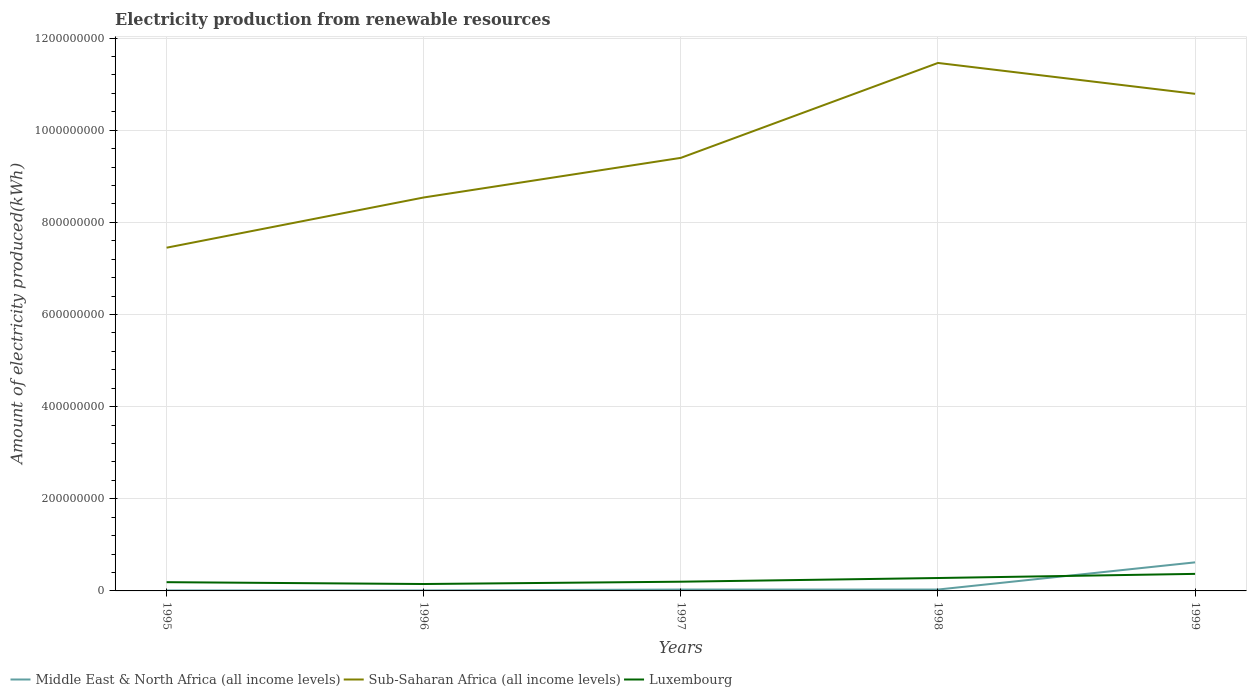Across all years, what is the maximum amount of electricity produced in Luxembourg?
Provide a succinct answer. 1.50e+07. What is the total amount of electricity produced in Sub-Saharan Africa (all income levels) in the graph?
Ensure brevity in your answer.  -1.39e+08. What is the difference between the highest and the second highest amount of electricity produced in Sub-Saharan Africa (all income levels)?
Your answer should be compact. 4.01e+08. What is the difference between the highest and the lowest amount of electricity produced in Sub-Saharan Africa (all income levels)?
Give a very brief answer. 2. Is the amount of electricity produced in Middle East & North Africa (all income levels) strictly greater than the amount of electricity produced in Sub-Saharan Africa (all income levels) over the years?
Offer a very short reply. Yes. How many years are there in the graph?
Your answer should be very brief. 5. What is the difference between two consecutive major ticks on the Y-axis?
Provide a succinct answer. 2.00e+08. Are the values on the major ticks of Y-axis written in scientific E-notation?
Provide a succinct answer. No. Where does the legend appear in the graph?
Offer a terse response. Bottom left. How many legend labels are there?
Your answer should be compact. 3. How are the legend labels stacked?
Provide a succinct answer. Horizontal. What is the title of the graph?
Make the answer very short. Electricity production from renewable resources. Does "Haiti" appear as one of the legend labels in the graph?
Your response must be concise. No. What is the label or title of the Y-axis?
Your answer should be compact. Amount of electricity produced(kWh). What is the Amount of electricity produced(kWh) in Middle East & North Africa (all income levels) in 1995?
Give a very brief answer. 1.00e+06. What is the Amount of electricity produced(kWh) of Sub-Saharan Africa (all income levels) in 1995?
Provide a short and direct response. 7.45e+08. What is the Amount of electricity produced(kWh) of Luxembourg in 1995?
Offer a terse response. 1.90e+07. What is the Amount of electricity produced(kWh) of Sub-Saharan Africa (all income levels) in 1996?
Keep it short and to the point. 8.54e+08. What is the Amount of electricity produced(kWh) of Luxembourg in 1996?
Your response must be concise. 1.50e+07. What is the Amount of electricity produced(kWh) in Sub-Saharan Africa (all income levels) in 1997?
Your answer should be compact. 9.40e+08. What is the Amount of electricity produced(kWh) in Luxembourg in 1997?
Provide a succinct answer. 2.00e+07. What is the Amount of electricity produced(kWh) in Middle East & North Africa (all income levels) in 1998?
Offer a terse response. 3.00e+06. What is the Amount of electricity produced(kWh) in Sub-Saharan Africa (all income levels) in 1998?
Provide a short and direct response. 1.15e+09. What is the Amount of electricity produced(kWh) in Luxembourg in 1998?
Provide a succinct answer. 2.80e+07. What is the Amount of electricity produced(kWh) of Middle East & North Africa (all income levels) in 1999?
Your answer should be very brief. 6.20e+07. What is the Amount of electricity produced(kWh) in Sub-Saharan Africa (all income levels) in 1999?
Offer a very short reply. 1.08e+09. What is the Amount of electricity produced(kWh) in Luxembourg in 1999?
Provide a short and direct response. 3.70e+07. Across all years, what is the maximum Amount of electricity produced(kWh) in Middle East & North Africa (all income levels)?
Keep it short and to the point. 6.20e+07. Across all years, what is the maximum Amount of electricity produced(kWh) in Sub-Saharan Africa (all income levels)?
Your answer should be very brief. 1.15e+09. Across all years, what is the maximum Amount of electricity produced(kWh) in Luxembourg?
Provide a short and direct response. 3.70e+07. Across all years, what is the minimum Amount of electricity produced(kWh) in Middle East & North Africa (all income levels)?
Your answer should be very brief. 1.00e+06. Across all years, what is the minimum Amount of electricity produced(kWh) of Sub-Saharan Africa (all income levels)?
Make the answer very short. 7.45e+08. Across all years, what is the minimum Amount of electricity produced(kWh) in Luxembourg?
Ensure brevity in your answer.  1.50e+07. What is the total Amount of electricity produced(kWh) in Middle East & North Africa (all income levels) in the graph?
Ensure brevity in your answer.  7.00e+07. What is the total Amount of electricity produced(kWh) in Sub-Saharan Africa (all income levels) in the graph?
Give a very brief answer. 4.76e+09. What is the total Amount of electricity produced(kWh) of Luxembourg in the graph?
Provide a succinct answer. 1.19e+08. What is the difference between the Amount of electricity produced(kWh) of Middle East & North Africa (all income levels) in 1995 and that in 1996?
Give a very brief answer. 0. What is the difference between the Amount of electricity produced(kWh) of Sub-Saharan Africa (all income levels) in 1995 and that in 1996?
Offer a terse response. -1.09e+08. What is the difference between the Amount of electricity produced(kWh) of Luxembourg in 1995 and that in 1996?
Offer a terse response. 4.00e+06. What is the difference between the Amount of electricity produced(kWh) of Sub-Saharan Africa (all income levels) in 1995 and that in 1997?
Keep it short and to the point. -1.95e+08. What is the difference between the Amount of electricity produced(kWh) in Sub-Saharan Africa (all income levels) in 1995 and that in 1998?
Make the answer very short. -4.01e+08. What is the difference between the Amount of electricity produced(kWh) in Luxembourg in 1995 and that in 1998?
Offer a very short reply. -9.00e+06. What is the difference between the Amount of electricity produced(kWh) in Middle East & North Africa (all income levels) in 1995 and that in 1999?
Provide a succinct answer. -6.10e+07. What is the difference between the Amount of electricity produced(kWh) in Sub-Saharan Africa (all income levels) in 1995 and that in 1999?
Offer a very short reply. -3.34e+08. What is the difference between the Amount of electricity produced(kWh) of Luxembourg in 1995 and that in 1999?
Ensure brevity in your answer.  -1.80e+07. What is the difference between the Amount of electricity produced(kWh) in Middle East & North Africa (all income levels) in 1996 and that in 1997?
Your response must be concise. -2.00e+06. What is the difference between the Amount of electricity produced(kWh) in Sub-Saharan Africa (all income levels) in 1996 and that in 1997?
Offer a terse response. -8.60e+07. What is the difference between the Amount of electricity produced(kWh) in Luxembourg in 1996 and that in 1997?
Offer a terse response. -5.00e+06. What is the difference between the Amount of electricity produced(kWh) in Middle East & North Africa (all income levels) in 1996 and that in 1998?
Your answer should be compact. -2.00e+06. What is the difference between the Amount of electricity produced(kWh) in Sub-Saharan Africa (all income levels) in 1996 and that in 1998?
Provide a short and direct response. -2.92e+08. What is the difference between the Amount of electricity produced(kWh) in Luxembourg in 1996 and that in 1998?
Your answer should be very brief. -1.30e+07. What is the difference between the Amount of electricity produced(kWh) of Middle East & North Africa (all income levels) in 1996 and that in 1999?
Offer a very short reply. -6.10e+07. What is the difference between the Amount of electricity produced(kWh) in Sub-Saharan Africa (all income levels) in 1996 and that in 1999?
Your answer should be very brief. -2.25e+08. What is the difference between the Amount of electricity produced(kWh) in Luxembourg in 1996 and that in 1999?
Ensure brevity in your answer.  -2.20e+07. What is the difference between the Amount of electricity produced(kWh) in Middle East & North Africa (all income levels) in 1997 and that in 1998?
Offer a very short reply. 0. What is the difference between the Amount of electricity produced(kWh) of Sub-Saharan Africa (all income levels) in 1997 and that in 1998?
Your response must be concise. -2.06e+08. What is the difference between the Amount of electricity produced(kWh) of Luxembourg in 1997 and that in 1998?
Keep it short and to the point. -8.00e+06. What is the difference between the Amount of electricity produced(kWh) of Middle East & North Africa (all income levels) in 1997 and that in 1999?
Your response must be concise. -5.90e+07. What is the difference between the Amount of electricity produced(kWh) of Sub-Saharan Africa (all income levels) in 1997 and that in 1999?
Make the answer very short. -1.39e+08. What is the difference between the Amount of electricity produced(kWh) of Luxembourg in 1997 and that in 1999?
Offer a very short reply. -1.70e+07. What is the difference between the Amount of electricity produced(kWh) of Middle East & North Africa (all income levels) in 1998 and that in 1999?
Your answer should be very brief. -5.90e+07. What is the difference between the Amount of electricity produced(kWh) of Sub-Saharan Africa (all income levels) in 1998 and that in 1999?
Your answer should be very brief. 6.70e+07. What is the difference between the Amount of electricity produced(kWh) of Luxembourg in 1998 and that in 1999?
Provide a succinct answer. -9.00e+06. What is the difference between the Amount of electricity produced(kWh) of Middle East & North Africa (all income levels) in 1995 and the Amount of electricity produced(kWh) of Sub-Saharan Africa (all income levels) in 1996?
Your response must be concise. -8.53e+08. What is the difference between the Amount of electricity produced(kWh) in Middle East & North Africa (all income levels) in 1995 and the Amount of electricity produced(kWh) in Luxembourg in 1996?
Provide a short and direct response. -1.40e+07. What is the difference between the Amount of electricity produced(kWh) in Sub-Saharan Africa (all income levels) in 1995 and the Amount of electricity produced(kWh) in Luxembourg in 1996?
Keep it short and to the point. 7.30e+08. What is the difference between the Amount of electricity produced(kWh) in Middle East & North Africa (all income levels) in 1995 and the Amount of electricity produced(kWh) in Sub-Saharan Africa (all income levels) in 1997?
Keep it short and to the point. -9.39e+08. What is the difference between the Amount of electricity produced(kWh) in Middle East & North Africa (all income levels) in 1995 and the Amount of electricity produced(kWh) in Luxembourg in 1997?
Offer a terse response. -1.90e+07. What is the difference between the Amount of electricity produced(kWh) in Sub-Saharan Africa (all income levels) in 1995 and the Amount of electricity produced(kWh) in Luxembourg in 1997?
Provide a short and direct response. 7.25e+08. What is the difference between the Amount of electricity produced(kWh) of Middle East & North Africa (all income levels) in 1995 and the Amount of electricity produced(kWh) of Sub-Saharan Africa (all income levels) in 1998?
Provide a short and direct response. -1.14e+09. What is the difference between the Amount of electricity produced(kWh) of Middle East & North Africa (all income levels) in 1995 and the Amount of electricity produced(kWh) of Luxembourg in 1998?
Your answer should be very brief. -2.70e+07. What is the difference between the Amount of electricity produced(kWh) in Sub-Saharan Africa (all income levels) in 1995 and the Amount of electricity produced(kWh) in Luxembourg in 1998?
Provide a short and direct response. 7.17e+08. What is the difference between the Amount of electricity produced(kWh) of Middle East & North Africa (all income levels) in 1995 and the Amount of electricity produced(kWh) of Sub-Saharan Africa (all income levels) in 1999?
Keep it short and to the point. -1.08e+09. What is the difference between the Amount of electricity produced(kWh) of Middle East & North Africa (all income levels) in 1995 and the Amount of electricity produced(kWh) of Luxembourg in 1999?
Keep it short and to the point. -3.60e+07. What is the difference between the Amount of electricity produced(kWh) in Sub-Saharan Africa (all income levels) in 1995 and the Amount of electricity produced(kWh) in Luxembourg in 1999?
Your answer should be compact. 7.08e+08. What is the difference between the Amount of electricity produced(kWh) of Middle East & North Africa (all income levels) in 1996 and the Amount of electricity produced(kWh) of Sub-Saharan Africa (all income levels) in 1997?
Keep it short and to the point. -9.39e+08. What is the difference between the Amount of electricity produced(kWh) of Middle East & North Africa (all income levels) in 1996 and the Amount of electricity produced(kWh) of Luxembourg in 1997?
Your response must be concise. -1.90e+07. What is the difference between the Amount of electricity produced(kWh) in Sub-Saharan Africa (all income levels) in 1996 and the Amount of electricity produced(kWh) in Luxembourg in 1997?
Offer a very short reply. 8.34e+08. What is the difference between the Amount of electricity produced(kWh) of Middle East & North Africa (all income levels) in 1996 and the Amount of electricity produced(kWh) of Sub-Saharan Africa (all income levels) in 1998?
Give a very brief answer. -1.14e+09. What is the difference between the Amount of electricity produced(kWh) in Middle East & North Africa (all income levels) in 1996 and the Amount of electricity produced(kWh) in Luxembourg in 1998?
Your response must be concise. -2.70e+07. What is the difference between the Amount of electricity produced(kWh) of Sub-Saharan Africa (all income levels) in 1996 and the Amount of electricity produced(kWh) of Luxembourg in 1998?
Your answer should be compact. 8.26e+08. What is the difference between the Amount of electricity produced(kWh) in Middle East & North Africa (all income levels) in 1996 and the Amount of electricity produced(kWh) in Sub-Saharan Africa (all income levels) in 1999?
Ensure brevity in your answer.  -1.08e+09. What is the difference between the Amount of electricity produced(kWh) of Middle East & North Africa (all income levels) in 1996 and the Amount of electricity produced(kWh) of Luxembourg in 1999?
Keep it short and to the point. -3.60e+07. What is the difference between the Amount of electricity produced(kWh) in Sub-Saharan Africa (all income levels) in 1996 and the Amount of electricity produced(kWh) in Luxembourg in 1999?
Give a very brief answer. 8.17e+08. What is the difference between the Amount of electricity produced(kWh) of Middle East & North Africa (all income levels) in 1997 and the Amount of electricity produced(kWh) of Sub-Saharan Africa (all income levels) in 1998?
Give a very brief answer. -1.14e+09. What is the difference between the Amount of electricity produced(kWh) of Middle East & North Africa (all income levels) in 1997 and the Amount of electricity produced(kWh) of Luxembourg in 1998?
Give a very brief answer. -2.50e+07. What is the difference between the Amount of electricity produced(kWh) in Sub-Saharan Africa (all income levels) in 1997 and the Amount of electricity produced(kWh) in Luxembourg in 1998?
Keep it short and to the point. 9.12e+08. What is the difference between the Amount of electricity produced(kWh) of Middle East & North Africa (all income levels) in 1997 and the Amount of electricity produced(kWh) of Sub-Saharan Africa (all income levels) in 1999?
Your answer should be very brief. -1.08e+09. What is the difference between the Amount of electricity produced(kWh) in Middle East & North Africa (all income levels) in 1997 and the Amount of electricity produced(kWh) in Luxembourg in 1999?
Offer a terse response. -3.40e+07. What is the difference between the Amount of electricity produced(kWh) in Sub-Saharan Africa (all income levels) in 1997 and the Amount of electricity produced(kWh) in Luxembourg in 1999?
Your answer should be compact. 9.03e+08. What is the difference between the Amount of electricity produced(kWh) of Middle East & North Africa (all income levels) in 1998 and the Amount of electricity produced(kWh) of Sub-Saharan Africa (all income levels) in 1999?
Offer a terse response. -1.08e+09. What is the difference between the Amount of electricity produced(kWh) of Middle East & North Africa (all income levels) in 1998 and the Amount of electricity produced(kWh) of Luxembourg in 1999?
Your answer should be compact. -3.40e+07. What is the difference between the Amount of electricity produced(kWh) in Sub-Saharan Africa (all income levels) in 1998 and the Amount of electricity produced(kWh) in Luxembourg in 1999?
Keep it short and to the point. 1.11e+09. What is the average Amount of electricity produced(kWh) in Middle East & North Africa (all income levels) per year?
Offer a terse response. 1.40e+07. What is the average Amount of electricity produced(kWh) of Sub-Saharan Africa (all income levels) per year?
Offer a very short reply. 9.53e+08. What is the average Amount of electricity produced(kWh) in Luxembourg per year?
Your answer should be very brief. 2.38e+07. In the year 1995, what is the difference between the Amount of electricity produced(kWh) in Middle East & North Africa (all income levels) and Amount of electricity produced(kWh) in Sub-Saharan Africa (all income levels)?
Your answer should be very brief. -7.44e+08. In the year 1995, what is the difference between the Amount of electricity produced(kWh) of Middle East & North Africa (all income levels) and Amount of electricity produced(kWh) of Luxembourg?
Offer a very short reply. -1.80e+07. In the year 1995, what is the difference between the Amount of electricity produced(kWh) of Sub-Saharan Africa (all income levels) and Amount of electricity produced(kWh) of Luxembourg?
Make the answer very short. 7.26e+08. In the year 1996, what is the difference between the Amount of electricity produced(kWh) of Middle East & North Africa (all income levels) and Amount of electricity produced(kWh) of Sub-Saharan Africa (all income levels)?
Make the answer very short. -8.53e+08. In the year 1996, what is the difference between the Amount of electricity produced(kWh) of Middle East & North Africa (all income levels) and Amount of electricity produced(kWh) of Luxembourg?
Give a very brief answer. -1.40e+07. In the year 1996, what is the difference between the Amount of electricity produced(kWh) in Sub-Saharan Africa (all income levels) and Amount of electricity produced(kWh) in Luxembourg?
Give a very brief answer. 8.39e+08. In the year 1997, what is the difference between the Amount of electricity produced(kWh) of Middle East & North Africa (all income levels) and Amount of electricity produced(kWh) of Sub-Saharan Africa (all income levels)?
Provide a short and direct response. -9.37e+08. In the year 1997, what is the difference between the Amount of electricity produced(kWh) in Middle East & North Africa (all income levels) and Amount of electricity produced(kWh) in Luxembourg?
Give a very brief answer. -1.70e+07. In the year 1997, what is the difference between the Amount of electricity produced(kWh) of Sub-Saharan Africa (all income levels) and Amount of electricity produced(kWh) of Luxembourg?
Keep it short and to the point. 9.20e+08. In the year 1998, what is the difference between the Amount of electricity produced(kWh) in Middle East & North Africa (all income levels) and Amount of electricity produced(kWh) in Sub-Saharan Africa (all income levels)?
Provide a short and direct response. -1.14e+09. In the year 1998, what is the difference between the Amount of electricity produced(kWh) in Middle East & North Africa (all income levels) and Amount of electricity produced(kWh) in Luxembourg?
Your response must be concise. -2.50e+07. In the year 1998, what is the difference between the Amount of electricity produced(kWh) in Sub-Saharan Africa (all income levels) and Amount of electricity produced(kWh) in Luxembourg?
Ensure brevity in your answer.  1.12e+09. In the year 1999, what is the difference between the Amount of electricity produced(kWh) of Middle East & North Africa (all income levels) and Amount of electricity produced(kWh) of Sub-Saharan Africa (all income levels)?
Your answer should be very brief. -1.02e+09. In the year 1999, what is the difference between the Amount of electricity produced(kWh) in Middle East & North Africa (all income levels) and Amount of electricity produced(kWh) in Luxembourg?
Give a very brief answer. 2.50e+07. In the year 1999, what is the difference between the Amount of electricity produced(kWh) in Sub-Saharan Africa (all income levels) and Amount of electricity produced(kWh) in Luxembourg?
Give a very brief answer. 1.04e+09. What is the ratio of the Amount of electricity produced(kWh) of Middle East & North Africa (all income levels) in 1995 to that in 1996?
Ensure brevity in your answer.  1. What is the ratio of the Amount of electricity produced(kWh) in Sub-Saharan Africa (all income levels) in 1995 to that in 1996?
Make the answer very short. 0.87. What is the ratio of the Amount of electricity produced(kWh) of Luxembourg in 1995 to that in 1996?
Your answer should be compact. 1.27. What is the ratio of the Amount of electricity produced(kWh) in Middle East & North Africa (all income levels) in 1995 to that in 1997?
Ensure brevity in your answer.  0.33. What is the ratio of the Amount of electricity produced(kWh) of Sub-Saharan Africa (all income levels) in 1995 to that in 1997?
Make the answer very short. 0.79. What is the ratio of the Amount of electricity produced(kWh) in Middle East & North Africa (all income levels) in 1995 to that in 1998?
Offer a terse response. 0.33. What is the ratio of the Amount of electricity produced(kWh) of Sub-Saharan Africa (all income levels) in 1995 to that in 1998?
Make the answer very short. 0.65. What is the ratio of the Amount of electricity produced(kWh) in Luxembourg in 1995 to that in 1998?
Your answer should be very brief. 0.68. What is the ratio of the Amount of electricity produced(kWh) of Middle East & North Africa (all income levels) in 1995 to that in 1999?
Give a very brief answer. 0.02. What is the ratio of the Amount of electricity produced(kWh) of Sub-Saharan Africa (all income levels) in 1995 to that in 1999?
Give a very brief answer. 0.69. What is the ratio of the Amount of electricity produced(kWh) in Luxembourg in 1995 to that in 1999?
Provide a succinct answer. 0.51. What is the ratio of the Amount of electricity produced(kWh) in Middle East & North Africa (all income levels) in 1996 to that in 1997?
Ensure brevity in your answer.  0.33. What is the ratio of the Amount of electricity produced(kWh) in Sub-Saharan Africa (all income levels) in 1996 to that in 1997?
Provide a short and direct response. 0.91. What is the ratio of the Amount of electricity produced(kWh) in Luxembourg in 1996 to that in 1997?
Your answer should be compact. 0.75. What is the ratio of the Amount of electricity produced(kWh) in Sub-Saharan Africa (all income levels) in 1996 to that in 1998?
Provide a succinct answer. 0.75. What is the ratio of the Amount of electricity produced(kWh) of Luxembourg in 1996 to that in 1998?
Offer a very short reply. 0.54. What is the ratio of the Amount of electricity produced(kWh) in Middle East & North Africa (all income levels) in 1996 to that in 1999?
Offer a terse response. 0.02. What is the ratio of the Amount of electricity produced(kWh) in Sub-Saharan Africa (all income levels) in 1996 to that in 1999?
Offer a terse response. 0.79. What is the ratio of the Amount of electricity produced(kWh) in Luxembourg in 1996 to that in 1999?
Provide a succinct answer. 0.41. What is the ratio of the Amount of electricity produced(kWh) of Sub-Saharan Africa (all income levels) in 1997 to that in 1998?
Keep it short and to the point. 0.82. What is the ratio of the Amount of electricity produced(kWh) in Luxembourg in 1997 to that in 1998?
Make the answer very short. 0.71. What is the ratio of the Amount of electricity produced(kWh) in Middle East & North Africa (all income levels) in 1997 to that in 1999?
Your answer should be very brief. 0.05. What is the ratio of the Amount of electricity produced(kWh) of Sub-Saharan Africa (all income levels) in 1997 to that in 1999?
Offer a terse response. 0.87. What is the ratio of the Amount of electricity produced(kWh) of Luxembourg in 1997 to that in 1999?
Give a very brief answer. 0.54. What is the ratio of the Amount of electricity produced(kWh) in Middle East & North Africa (all income levels) in 1998 to that in 1999?
Your response must be concise. 0.05. What is the ratio of the Amount of electricity produced(kWh) of Sub-Saharan Africa (all income levels) in 1998 to that in 1999?
Provide a short and direct response. 1.06. What is the ratio of the Amount of electricity produced(kWh) in Luxembourg in 1998 to that in 1999?
Give a very brief answer. 0.76. What is the difference between the highest and the second highest Amount of electricity produced(kWh) in Middle East & North Africa (all income levels)?
Your answer should be very brief. 5.90e+07. What is the difference between the highest and the second highest Amount of electricity produced(kWh) in Sub-Saharan Africa (all income levels)?
Make the answer very short. 6.70e+07. What is the difference between the highest and the second highest Amount of electricity produced(kWh) of Luxembourg?
Offer a terse response. 9.00e+06. What is the difference between the highest and the lowest Amount of electricity produced(kWh) of Middle East & North Africa (all income levels)?
Offer a terse response. 6.10e+07. What is the difference between the highest and the lowest Amount of electricity produced(kWh) in Sub-Saharan Africa (all income levels)?
Your answer should be very brief. 4.01e+08. What is the difference between the highest and the lowest Amount of electricity produced(kWh) in Luxembourg?
Provide a succinct answer. 2.20e+07. 